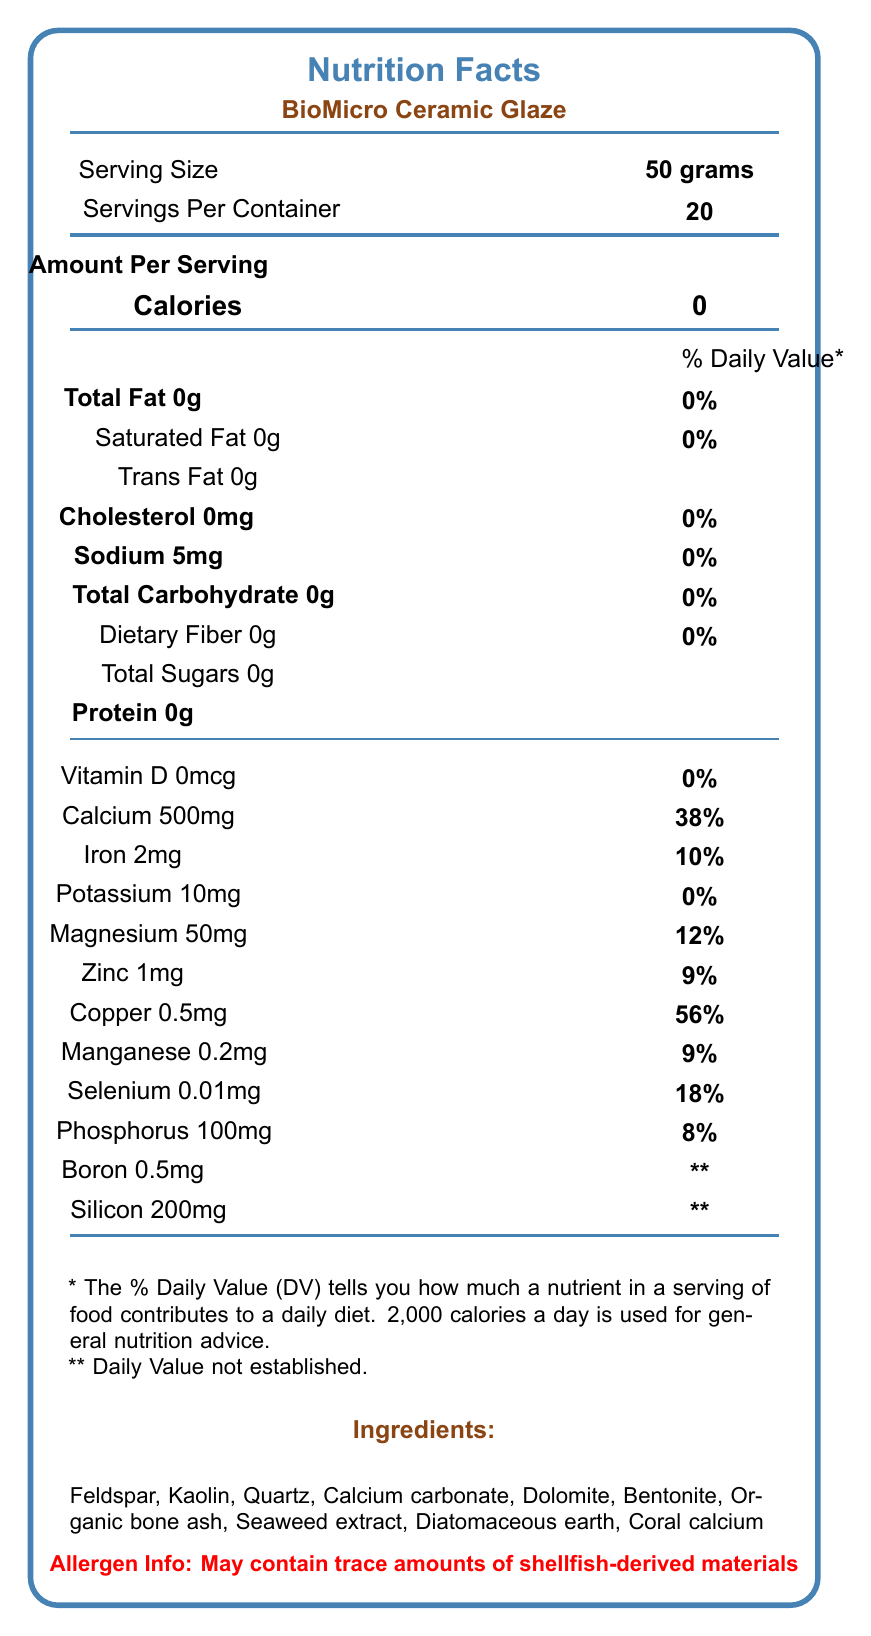what is the serving size of BioMicro Ceramic Glaze? The document states the serving size as "50 grams" in the Nutrition Facts section.
Answer: 50 grams how much calcium is in one serving? The document lists the amount of calcium as "500mg" per serving in the Nutrition Facts.
Answer: 500mg how many servings are in one container? The document states there are "20" servings per container in the Nutrition Facts section.
Answer: 20 what is the amount of sodium per serving? The document lists "Sodium 5mg" per serving in the Nutrition Facts section.
Answer: 5mg which ingredient may cause an allergic reaction? The allergen information states that the product "May contain trace amounts of shellfish-derived materials."
Answer: Shellfish-derived materials which certifications does the BioMicro Ceramic Glaze have? The document lists these certifications under the Certifications section.
Answer: FDA Approved, Non-Toxic, Eco-Friendly, Vegan-Friendly what should you do before final firing according to the usage instructions? The document specifies to "Apply thinly to bisque-fired ceramics before final firing" in the usage instructions.
Answer: Apply thinly to bisque-fired ceramics how should the product be stored? The document states to store the product in a "cool, dry place away from direct sunlight" under the storage section.
Answer: In a cool, dry place away from direct sunlight how much iron is in a serving? The document lists "Iron 2mg" per serving in the Nutrition Facts section.
Answer: 2mg how much protein is in the glaze? The document states that there is "Protein 0g" per serving in the Nutrition Facts section.
Answer: 0g what percentage of the daily value of calcium does one serving provide? The document indicates that one serving provides "38%" of the daily value of calcium.
Answer: 38% what is the total carbohydrate content per serving? The document lists "Total Carbohydrate 0g" per serving in the Nutrition Facts section.
Answer: 0g which of the following is NOT listed as an ingredient? A. Seaweed extract B. Corn starch C. Coral calcium The ingredients section does not list Corn starch, whereas Seaweed extract and Coral calcium are listed.
Answer: B which nutrient has the highest daily value percentage in one serving? A. Calcium B. Magnesium C. Copper D. Selenium The document lists Copper at 56%, which is the highest daily value percentage.
Answer: C is the BioMicro Ceramic Glaze safe for food contact surfaces? The usage instructions state that it is "Not for food contact surfaces."
Answer: No summarize the contents of the document. The summary encapsulates the main elements of the Nutrition Facts label and all pertinent sections, including nutrients, usage, storage, ingredients, and certifications.
Answer: The document is a detailed Nutrition Facts Label for BioMicro Ceramic Glaze, highlighting serving size, nutrient content, ingredients, allergen information, certifications, and usage and storage instructions. It provides specific details about the nutritional content, including minerals like calcium and iron, and emphasizes its eco-friendly and non-toxic certifications. how much silicon is in one serving of the glaze? The document lists "Silicon 200mg" per serving in the Nutrition Facts section.
Answer: 200mg what is the source of magnesium in BioMicro Ceramic Glaze? The document lists the amount of magnesium but does not specify the source among the ingredients.
Answer: Not enough information how much diatomaceous earth is in the product? The document lists diatomaceous earth as an ingredient but does not specify its quantity.
Answer: Cannot be determined what inspires the artist for this ceramic glaze? The artist note at the bottom of the document states that it is inspired by "the intricate structures of diatoms and radiolarians."
Answer: Intricate structures of diatoms and radiolarians 